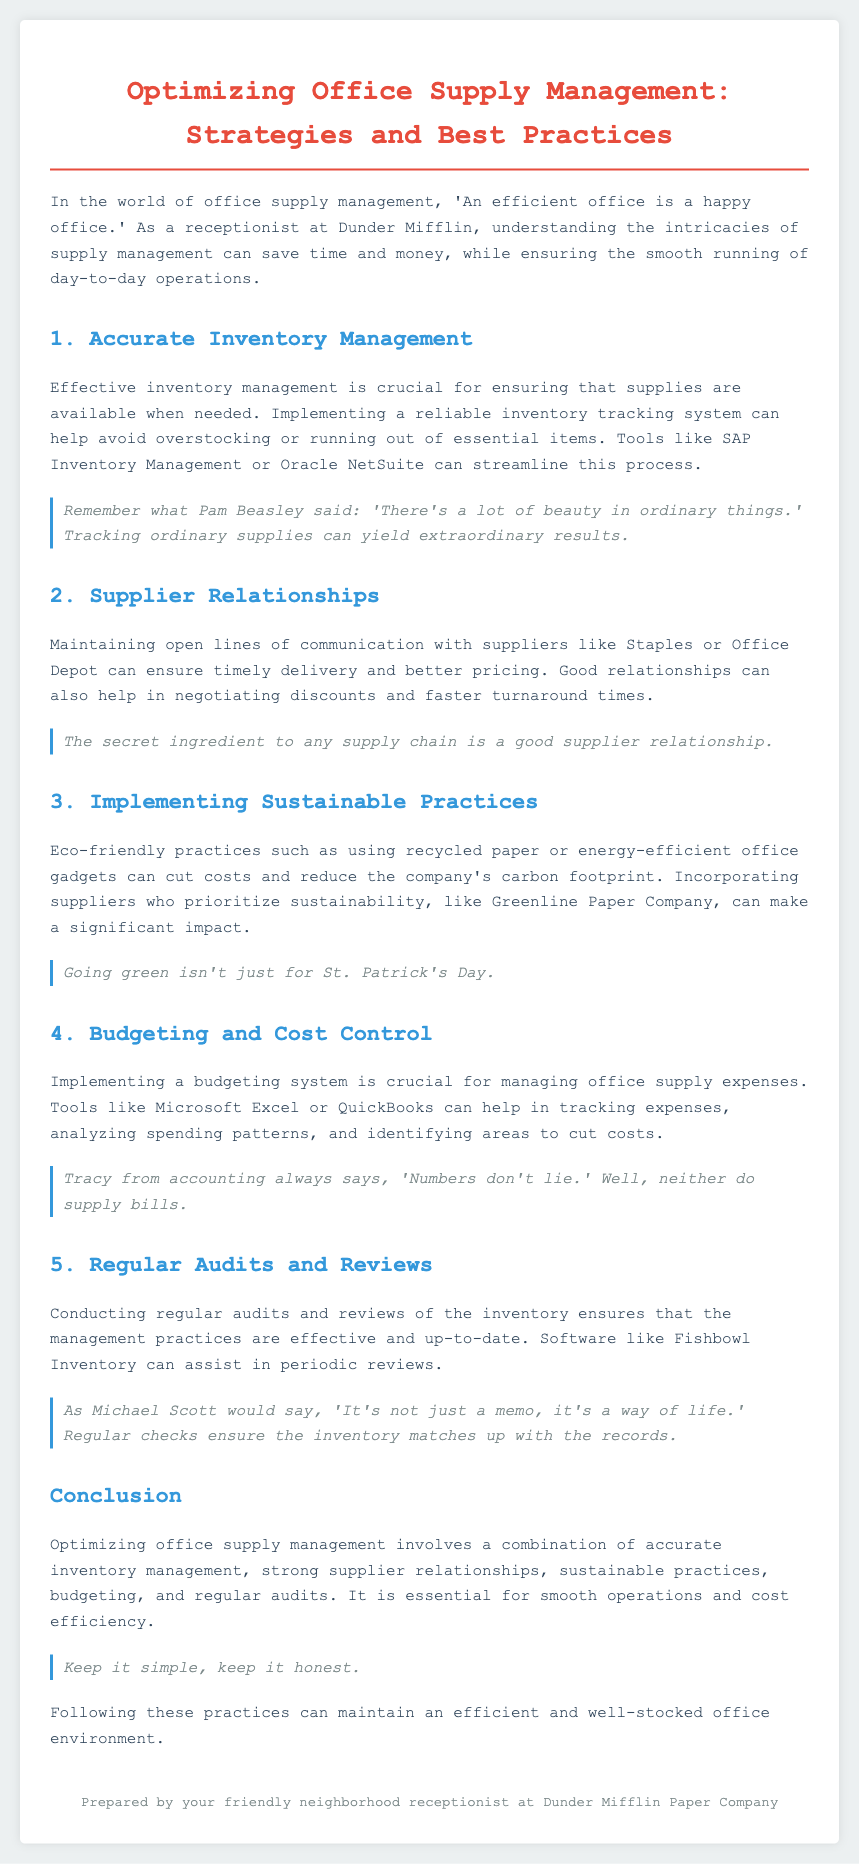What is the title of the whitepaper? The title is stated at the top of the document, introducing the main subject matter.
Answer: Optimizing Office Supply Management: Strategies and Best Practices What tracking tools are mentioned for inventory management? The document lists specific tools that can aid in inventory management.
Answer: SAP Inventory Management or Oracle NetSuite Which supplier is mentioned for maintaining good relationships? The document provides examples of suppliers to maintain relationships with for effective supply management.
Answer: Staples or Office Depot What eco-friendly practice is highlighted in the document? The document emphasizes a specific sustainable practice in office supply management.
Answer: Using recycled paper What budgeting tool is suggested for cost control? The document indicates tools to help with budgeting and tracking expenses.
Answer: Microsoft Excel or QuickBooks What is the key to maintaining an efficient office supply system according to the conclusion? The conclusion summarizes the essential practices for effective office supply management.
Answer: Accurate inventory management Which software is recommended for conducting audits and reviews? The document suggests a specific software suited for inventory audits and reviews.
Answer: Fishbowl Inventory Who is the author of the whitepaper? The author's identity is provided at the end of the document as part of a signature.
Answer: Your friendly neighborhood receptionist at Dunder Mifflin Paper Company What quote is attributed to Pam Beasley? A specific quote is used to highlight the importance of tracking office supplies.
Answer: There's a lot of beauty in ordinary things 